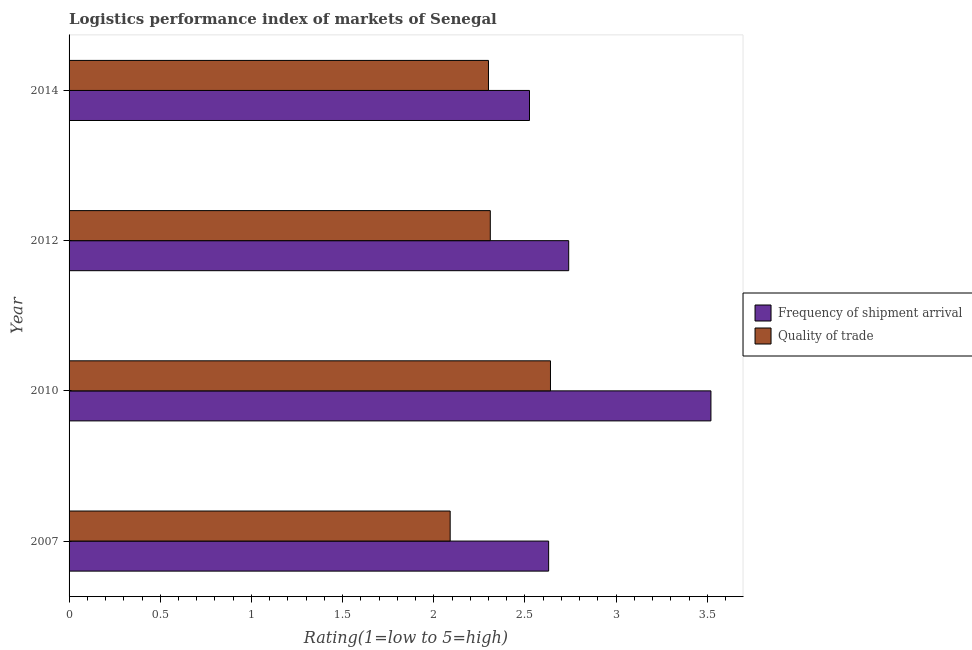Are the number of bars per tick equal to the number of legend labels?
Keep it short and to the point. Yes. Are the number of bars on each tick of the Y-axis equal?
Keep it short and to the point. Yes. How many bars are there on the 3rd tick from the top?
Make the answer very short. 2. In how many cases, is the number of bars for a given year not equal to the number of legend labels?
Keep it short and to the point. 0. What is the lpi of frequency of shipment arrival in 2012?
Offer a terse response. 2.74. Across all years, what is the maximum lpi quality of trade?
Your response must be concise. 2.64. Across all years, what is the minimum lpi quality of trade?
Keep it short and to the point. 2.09. In which year was the lpi quality of trade maximum?
Make the answer very short. 2010. What is the total lpi of frequency of shipment arrival in the graph?
Provide a short and direct response. 11.42. What is the difference between the lpi quality of trade in 2007 and that in 2014?
Offer a very short reply. -0.21. What is the difference between the lpi of frequency of shipment arrival in 2012 and the lpi quality of trade in 2007?
Your answer should be compact. 0.65. What is the average lpi quality of trade per year?
Make the answer very short. 2.33. In how many years, is the lpi quality of trade greater than 2.9 ?
Make the answer very short. 0. What is the ratio of the lpi of frequency of shipment arrival in 2012 to that in 2014?
Offer a terse response. 1.08. Is the lpi of frequency of shipment arrival in 2012 less than that in 2014?
Your response must be concise. No. What is the difference between the highest and the second highest lpi quality of trade?
Give a very brief answer. 0.33. What is the difference between the highest and the lowest lpi of frequency of shipment arrival?
Offer a terse response. 1. Is the sum of the lpi of frequency of shipment arrival in 2007 and 2012 greater than the maximum lpi quality of trade across all years?
Ensure brevity in your answer.  Yes. What does the 2nd bar from the top in 2007 represents?
Provide a succinct answer. Frequency of shipment arrival. What does the 1st bar from the bottom in 2010 represents?
Offer a very short reply. Frequency of shipment arrival. How many bars are there?
Keep it short and to the point. 8. What is the difference between two consecutive major ticks on the X-axis?
Provide a succinct answer. 0.5. Does the graph contain grids?
Provide a short and direct response. No. Where does the legend appear in the graph?
Your answer should be very brief. Center right. What is the title of the graph?
Offer a very short reply. Logistics performance index of markets of Senegal. Does "DAC donors" appear as one of the legend labels in the graph?
Offer a very short reply. No. What is the label or title of the X-axis?
Your answer should be compact. Rating(1=low to 5=high). What is the label or title of the Y-axis?
Offer a terse response. Year. What is the Rating(1=low to 5=high) of Frequency of shipment arrival in 2007?
Provide a succinct answer. 2.63. What is the Rating(1=low to 5=high) in Quality of trade in 2007?
Provide a succinct answer. 2.09. What is the Rating(1=low to 5=high) in Frequency of shipment arrival in 2010?
Your answer should be compact. 3.52. What is the Rating(1=low to 5=high) of Quality of trade in 2010?
Ensure brevity in your answer.  2.64. What is the Rating(1=low to 5=high) in Frequency of shipment arrival in 2012?
Provide a short and direct response. 2.74. What is the Rating(1=low to 5=high) of Quality of trade in 2012?
Keep it short and to the point. 2.31. What is the Rating(1=low to 5=high) in Frequency of shipment arrival in 2014?
Ensure brevity in your answer.  2.52. Across all years, what is the maximum Rating(1=low to 5=high) in Frequency of shipment arrival?
Offer a very short reply. 3.52. Across all years, what is the maximum Rating(1=low to 5=high) in Quality of trade?
Provide a succinct answer. 2.64. Across all years, what is the minimum Rating(1=low to 5=high) of Frequency of shipment arrival?
Your answer should be compact. 2.52. Across all years, what is the minimum Rating(1=low to 5=high) in Quality of trade?
Your answer should be compact. 2.09. What is the total Rating(1=low to 5=high) in Frequency of shipment arrival in the graph?
Offer a very short reply. 11.41. What is the total Rating(1=low to 5=high) in Quality of trade in the graph?
Make the answer very short. 9.34. What is the difference between the Rating(1=low to 5=high) in Frequency of shipment arrival in 2007 and that in 2010?
Your answer should be very brief. -0.89. What is the difference between the Rating(1=low to 5=high) of Quality of trade in 2007 and that in 2010?
Your answer should be very brief. -0.55. What is the difference between the Rating(1=low to 5=high) in Frequency of shipment arrival in 2007 and that in 2012?
Your response must be concise. -0.11. What is the difference between the Rating(1=low to 5=high) of Quality of trade in 2007 and that in 2012?
Your answer should be compact. -0.22. What is the difference between the Rating(1=low to 5=high) in Frequency of shipment arrival in 2007 and that in 2014?
Your answer should be very brief. 0.1. What is the difference between the Rating(1=low to 5=high) of Quality of trade in 2007 and that in 2014?
Make the answer very short. -0.21. What is the difference between the Rating(1=low to 5=high) in Frequency of shipment arrival in 2010 and that in 2012?
Make the answer very short. 0.78. What is the difference between the Rating(1=low to 5=high) of Quality of trade in 2010 and that in 2012?
Offer a terse response. 0.33. What is the difference between the Rating(1=low to 5=high) of Frequency of shipment arrival in 2010 and that in 2014?
Keep it short and to the point. 0.99. What is the difference between the Rating(1=low to 5=high) in Quality of trade in 2010 and that in 2014?
Give a very brief answer. 0.34. What is the difference between the Rating(1=low to 5=high) in Frequency of shipment arrival in 2012 and that in 2014?
Make the answer very short. 0.21. What is the difference between the Rating(1=low to 5=high) in Quality of trade in 2012 and that in 2014?
Offer a very short reply. 0.01. What is the difference between the Rating(1=low to 5=high) of Frequency of shipment arrival in 2007 and the Rating(1=low to 5=high) of Quality of trade in 2010?
Make the answer very short. -0.01. What is the difference between the Rating(1=low to 5=high) in Frequency of shipment arrival in 2007 and the Rating(1=low to 5=high) in Quality of trade in 2012?
Offer a very short reply. 0.32. What is the difference between the Rating(1=low to 5=high) of Frequency of shipment arrival in 2007 and the Rating(1=low to 5=high) of Quality of trade in 2014?
Ensure brevity in your answer.  0.33. What is the difference between the Rating(1=low to 5=high) of Frequency of shipment arrival in 2010 and the Rating(1=low to 5=high) of Quality of trade in 2012?
Offer a terse response. 1.21. What is the difference between the Rating(1=low to 5=high) in Frequency of shipment arrival in 2010 and the Rating(1=low to 5=high) in Quality of trade in 2014?
Keep it short and to the point. 1.22. What is the difference between the Rating(1=low to 5=high) of Frequency of shipment arrival in 2012 and the Rating(1=low to 5=high) of Quality of trade in 2014?
Provide a succinct answer. 0.44. What is the average Rating(1=low to 5=high) of Frequency of shipment arrival per year?
Your response must be concise. 2.85. What is the average Rating(1=low to 5=high) of Quality of trade per year?
Give a very brief answer. 2.33. In the year 2007, what is the difference between the Rating(1=low to 5=high) of Frequency of shipment arrival and Rating(1=low to 5=high) of Quality of trade?
Your answer should be very brief. 0.54. In the year 2012, what is the difference between the Rating(1=low to 5=high) in Frequency of shipment arrival and Rating(1=low to 5=high) in Quality of trade?
Provide a short and direct response. 0.43. In the year 2014, what is the difference between the Rating(1=low to 5=high) of Frequency of shipment arrival and Rating(1=low to 5=high) of Quality of trade?
Your answer should be compact. 0.23. What is the ratio of the Rating(1=low to 5=high) in Frequency of shipment arrival in 2007 to that in 2010?
Provide a succinct answer. 0.75. What is the ratio of the Rating(1=low to 5=high) in Quality of trade in 2007 to that in 2010?
Give a very brief answer. 0.79. What is the ratio of the Rating(1=low to 5=high) in Frequency of shipment arrival in 2007 to that in 2012?
Give a very brief answer. 0.96. What is the ratio of the Rating(1=low to 5=high) of Quality of trade in 2007 to that in 2012?
Offer a very short reply. 0.9. What is the ratio of the Rating(1=low to 5=high) in Frequency of shipment arrival in 2007 to that in 2014?
Your answer should be compact. 1.04. What is the ratio of the Rating(1=low to 5=high) in Quality of trade in 2007 to that in 2014?
Give a very brief answer. 0.91. What is the ratio of the Rating(1=low to 5=high) of Frequency of shipment arrival in 2010 to that in 2012?
Your response must be concise. 1.28. What is the ratio of the Rating(1=low to 5=high) in Quality of trade in 2010 to that in 2012?
Offer a terse response. 1.14. What is the ratio of the Rating(1=low to 5=high) in Frequency of shipment arrival in 2010 to that in 2014?
Your answer should be very brief. 1.39. What is the ratio of the Rating(1=low to 5=high) of Quality of trade in 2010 to that in 2014?
Your answer should be very brief. 1.15. What is the ratio of the Rating(1=low to 5=high) in Frequency of shipment arrival in 2012 to that in 2014?
Your response must be concise. 1.09. What is the difference between the highest and the second highest Rating(1=low to 5=high) in Frequency of shipment arrival?
Provide a succinct answer. 0.78. What is the difference between the highest and the second highest Rating(1=low to 5=high) of Quality of trade?
Give a very brief answer. 0.33. What is the difference between the highest and the lowest Rating(1=low to 5=high) in Quality of trade?
Your response must be concise. 0.55. 